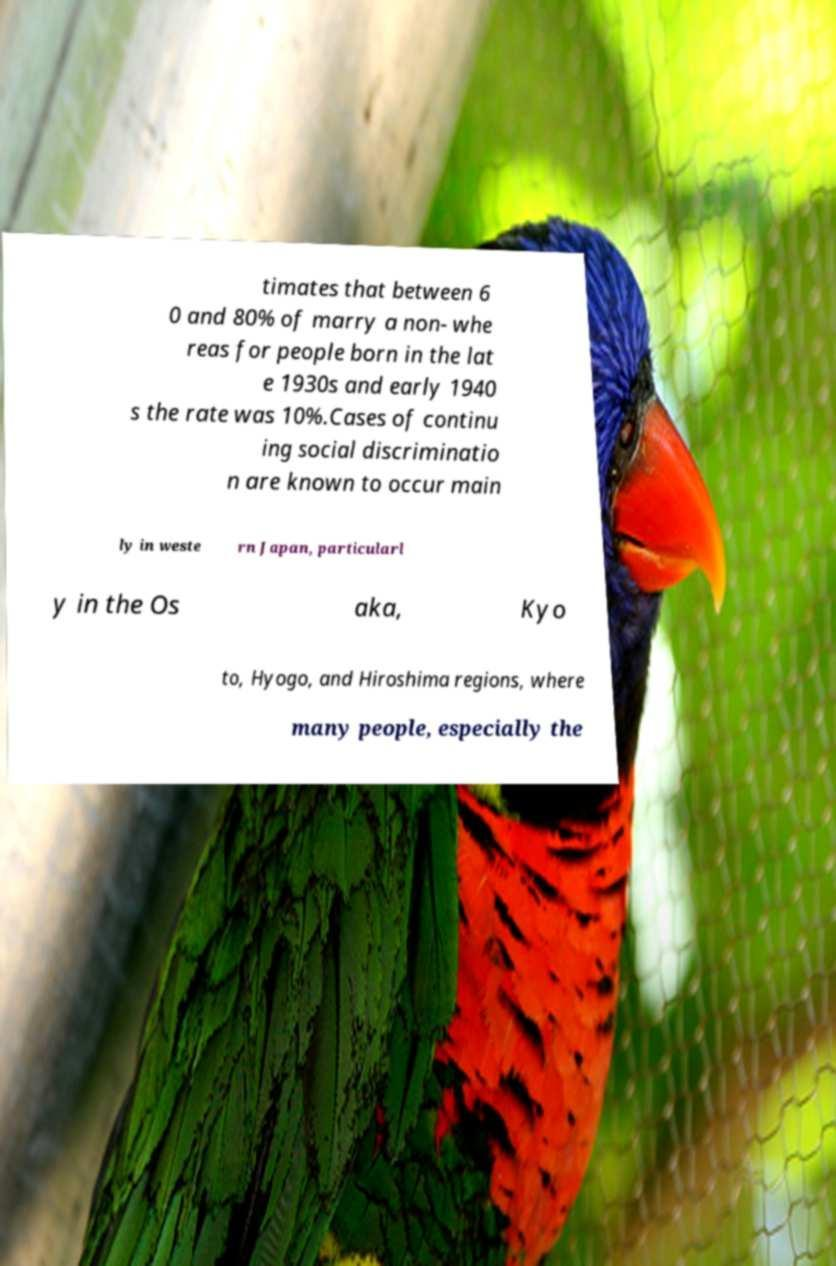Please identify and transcribe the text found in this image. timates that between 6 0 and 80% of marry a non- whe reas for people born in the lat e 1930s and early 1940 s the rate was 10%.Cases of continu ing social discriminatio n are known to occur main ly in weste rn Japan, particularl y in the Os aka, Kyo to, Hyogo, and Hiroshima regions, where many people, especially the 